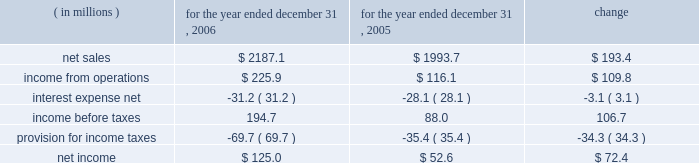Results of operations year ended december 31 , 2006 compared to year ended december 31 , 2005 the historical results of operations of pca for the years ended december 31 , 2006 and 2005 are set forth below : for the year ended december 31 , ( in millions ) 2006 2005 change .
Net sales net sales increased by $ 193.4 million , or 9.7% ( 9.7 % ) , for the year ended december 31 , 2006 from the year ended december 31 , 2005 .
Net sales increased primarily due to increased sales prices and volumes of corrugated products and containerboard compared to 2005 .
Total corrugated products volume sold increased 0.4% ( 0.4 % ) to 31.3 billion square feet in 2006 compared to 31.2 billion square feet in 2005 .
On a comparable shipment-per-workday basis , corrugated products sales volume increased 0.8% ( 0.8 % ) in 2006 from 2005 .
Shipments-per-workday is calculated by dividing our total corrugated products volume during the year by the number of workdays within the year .
The larger percentage increase on a shipment-per-workday basis was due to the fact that 2006 had one less workday ( 249 days ) , those days not falling on a weekend or holiday , than 2005 ( 250 days ) .
Containerboard sales volume to external domestic and export customers increased 15.6% ( 15.6 % ) to 482000 tons for the year ended december 31 , 2006 from 417000 tons in 2005 .
Income from operations income from operations increased by $ 109.8 million , or 94.6% ( 94.6 % ) , for the year ended december 31 , 2006 compared to 2005 .
Included in income from operations for the year ended december 31 , 2005 is income of $ 14.0 million , net of expenses , consisting of two dividends paid to pca by southern timber venture , llc ( stv ) , the timberlands joint venture in which pca owns a 311 20443% ( 20443 % ) ownership interest .
Excluding the dividends from stv , income from operations increased $ 123.8 million in 2006 compared to 2005 .
The $ 123.8 million increase in income from operations was primarily attributable to higher sales prices and volume as well as improved mix of business ( $ 195.6 million ) , partially offset by increased costs related to transportation ( $ 18.9 million ) , energy , primarily purchased fuels and electricity ( $ 18.3 million ) , wage increases for hourly and salaried personnel ( $ 16.9 million ) , medical , pension and other benefit costs ( $ 9.9 million ) , and incentive compensation ( $ 6.5 million ) .
Gross profit increased $ 137.1 million , or 44.7% ( 44.7 % ) , for the year ended december 31 , 2006 from the year ended december 31 , 2005 .
Gross profit as a percentage of net sales increased from 15.4% ( 15.4 % ) of net sales in 2005 to 20.3% ( 20.3 % ) of net sales in the current year primarily due to the increased sales prices described previously .
Selling and administrative expenses increased $ 12.3 million , or 8.4% ( 8.4 % ) , for the year ended december 31 , 2006 from the comparable period in 2005 .
The increase was primarily the result of increased salary and .
Total corrugated products volume sold increased by how many billion square feet in 2006 compared to 2005? 
Computations: (31.3 - 31.2)
Answer: 0.1. 